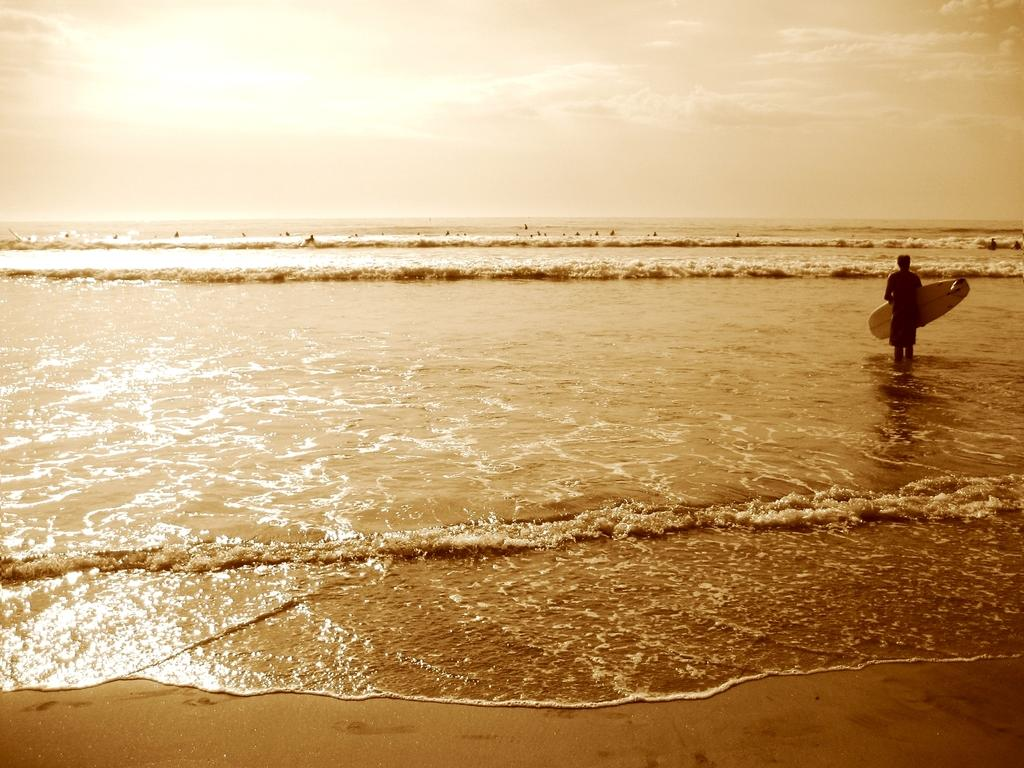What is the main subject of the image? There is a person in the image. What is the person holding in the image? The person is holding a surfboard. Where is the surfboard located in the image? The surfboard is in the water. What is visible at the top of the image? The sky is visible at the top of the image. What type of education can be seen in the image? There is no reference to education in the image; it features a person holding a surfboard in the water. What kind of oatmeal is being prepared in the image? There is no oatmeal or any cooking activity present in the image. 